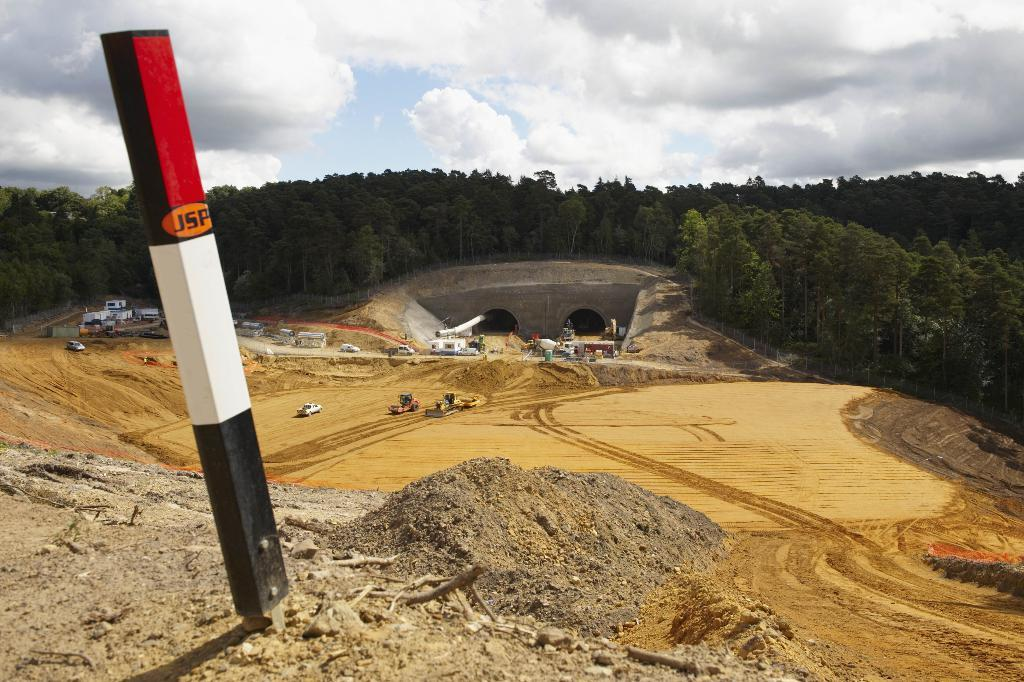What is located on the ground in the image? There is a pole on the ground in the image. What can be seen in the background of the image? There are two tunnels, the sky, and trees visible in the background of the image. What type of objects are on the ground in the image? Vehicles are visible on the ground in the image. What type of coat is the turkey wearing in the image? There is no turkey or coat present in the image. What is on top of the pole in the image? The provided facts do not mention anything on top of the pole, so we cannot answer this question definitively. 